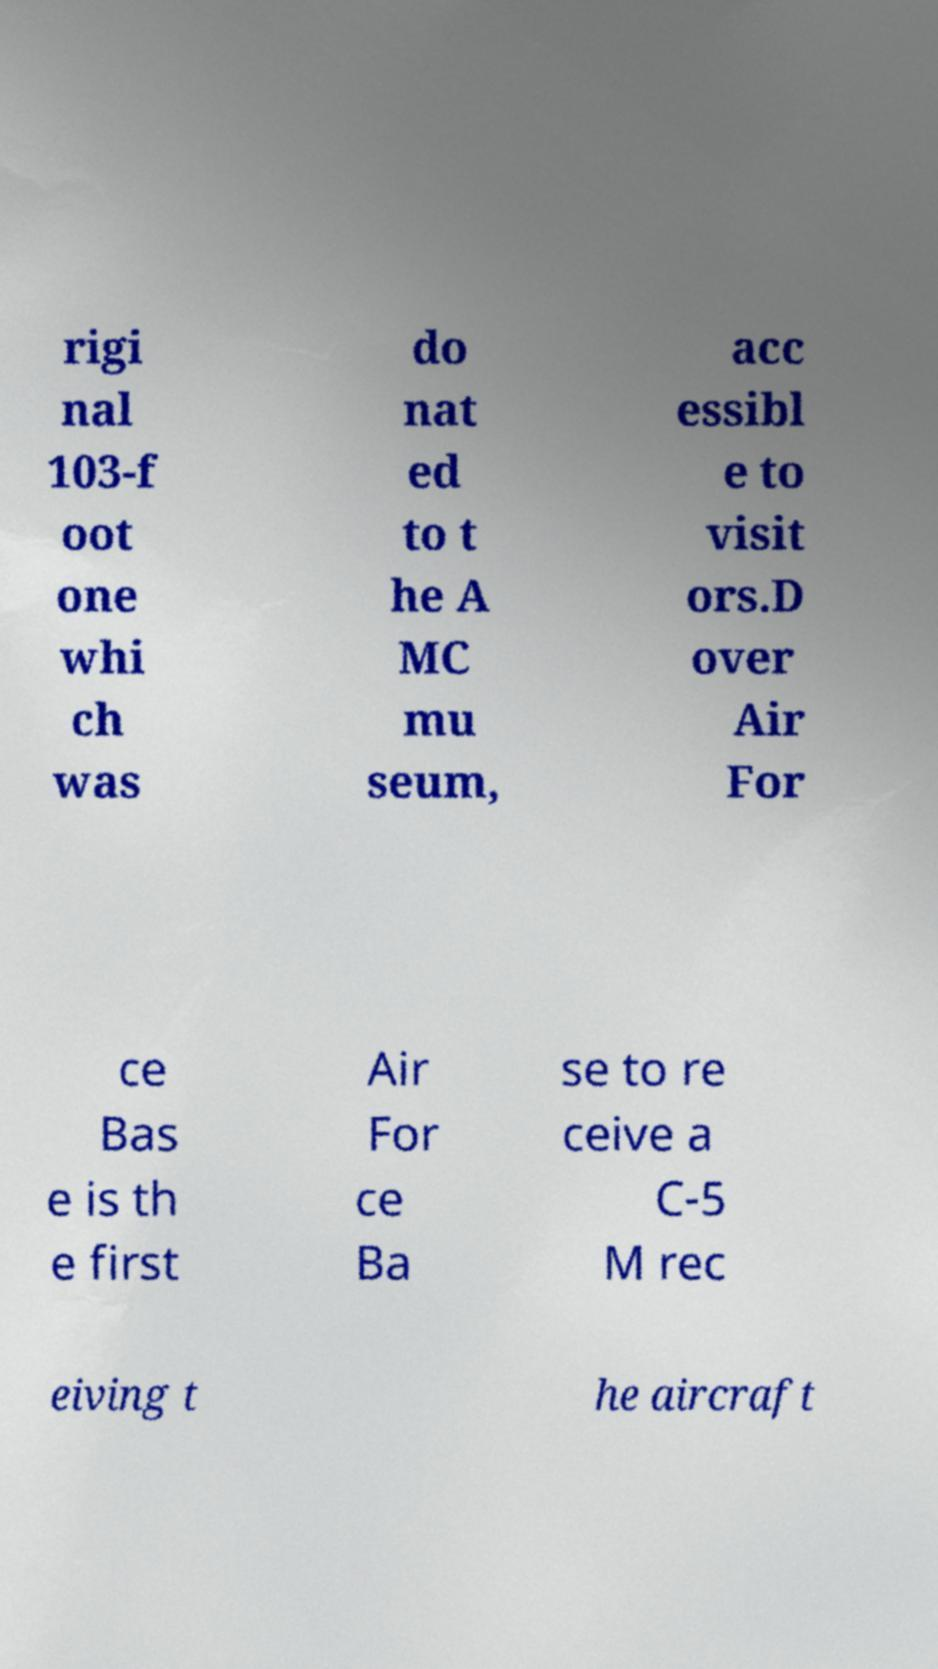I need the written content from this picture converted into text. Can you do that? rigi nal 103-f oot one whi ch was do nat ed to t he A MC mu seum, acc essibl e to visit ors.D over Air For ce Bas e is th e first Air For ce Ba se to re ceive a C-5 M rec eiving t he aircraft 